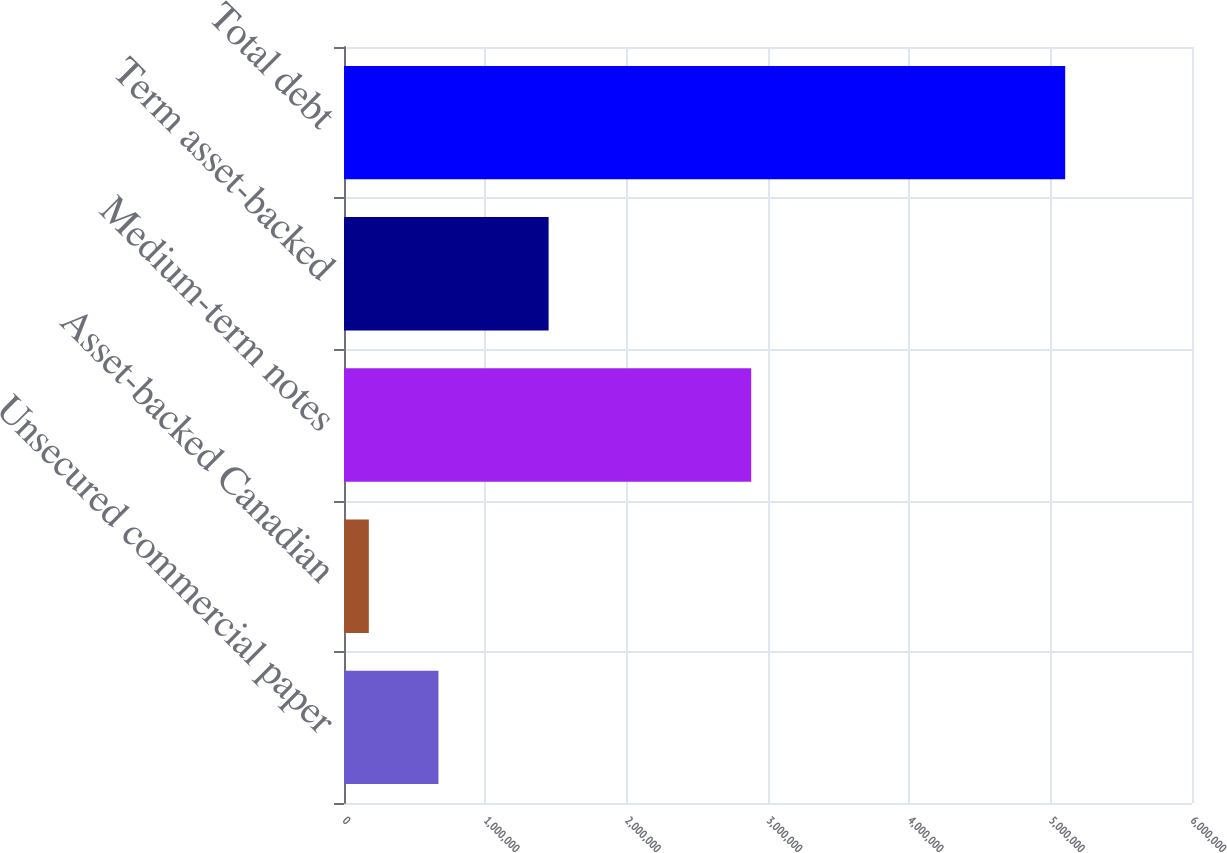Convert chart. <chart><loc_0><loc_0><loc_500><loc_500><bar_chart><fcel>Unsecured commercial paper<fcel>Asset-backed Canadian<fcel>Medium-term notes<fcel>Term asset-backed<fcel>Total debt<nl><fcel>668357<fcel>175658<fcel>2.88127e+06<fcel>1.44778e+06<fcel>5.10265e+06<nl></chart> 